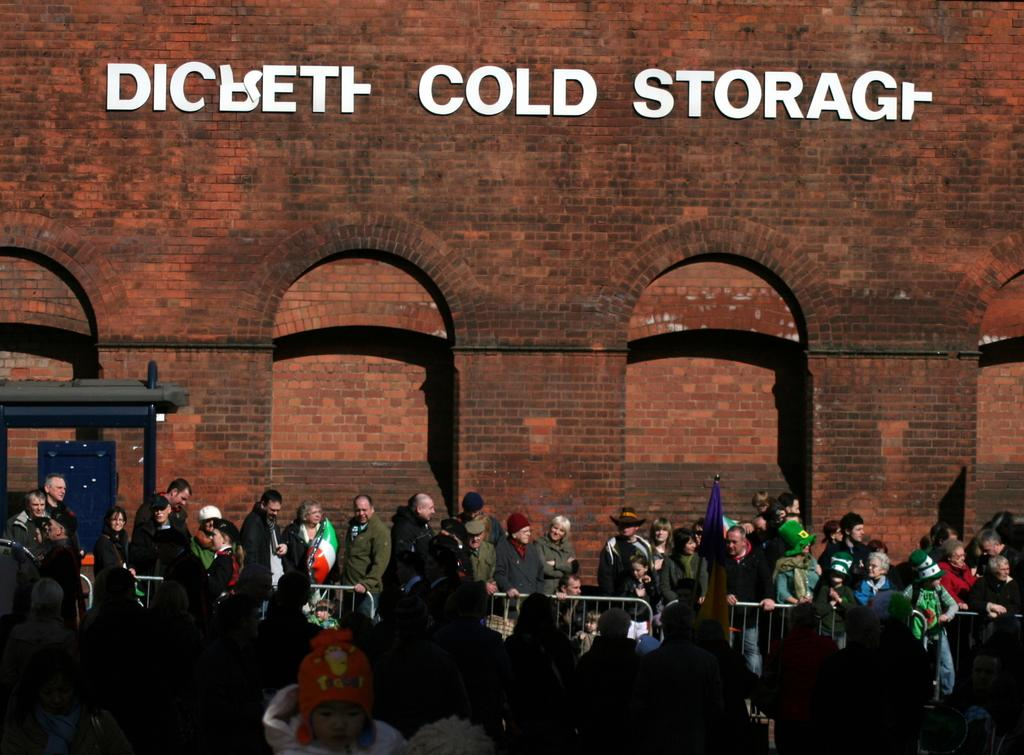What is happening in the center of the image? There are people standing in the center of the image. What can be seen in the image besides the people? There are flags, fences, a building, a wall, a banner, and other unspecified objects in the background of the image. Can you describe the flags in the image? The facts facts facts facts facts facts facts facts facts facts facts facts facts facts facts facts facts facts facts facts facts facts facts facts facts facts facts facts facts facts facts facts facts facts facts facts facts facts facts facts facts facts facts facts facts facts facts facts facts facts facts facts facts facts facts facts facts facts facts facts facts facts facts facts facts facts facts facts facts facts facts facts facts facts facts facts facts facts facts facts facts facts facts facts facts facts facts facts facts facts facts facts facts facts facts facts facts facts facts facts facts facts facts facts facts facts facts facts facts facts facts facts facts facts facts facts facts facts facts facts facts facts facts facts facts facts facts facts facts facts facts facts facts facts facts facts facts facts facts facts facts facts facts facts facts facts facts facts facts facts facts facts facts facts facts facts facts facts facts facts facts facts facts facts facts facts facts facts facts facts facts facts facts facts facts facts facts facts facts facts facts facts facts facts facts facts facts facts facts facts facts facts facts facts facts facts facts facts facts facts facts facts facts facts facts facts facts facts facts facts facts facts facts facts facts facts facts facts facts facts facts facts facts facts facts facts facts facts facts facts facts facts facts facts facts facts facts facts facts facts facts facts facts facts facts facts facts facts facts facts facts facts facts facts facts facts facts facts facts facts facts facts facts facts facts facts facts facts facts facts facts facts facts facts facts facts facts facts facts facts facts facts facts facts facts facts facts facts facts facts facts facts facts facts facts facts facts facts facts facts facts facts facts facts facts facts facts facts facts facts facts facts facts facts facts facts facts facts facts facts facts facts facts facts facts facts facts facts facts facts facts facts facts facts facts facts facts facts facts facts facts facts facts facts facts facts facts facts facts facts facts facts facts facts facts facts facts facts facts facts facts facts facts facts facts facts facts facts facts facts facts facts facts facts facts facts facts facts facts facts facts facts facts facts facts facts facts facts facts facts facts facts facts facts facts facts facts facts facts facts facts facts facts facts facts facts facts facts facts facts facts facts facts facts facts facts facts facts facts facts facts facts facts facts facts facts facts facts facts facts facts facts facts facts facts facts facts facts facts facts facts facts facts facts facts facts facts facts facts facts facts facts facts facts facts facts facts facts facts facts facts facts facts facts facts facts facts facts facts facts facts facts facts facts facts facts facts facts facts facts facts facts facts facts facts facts facts facts facts facts facts facts facts facts facts facts facts facts facts facts facts facts facts facts facts facts facts facts facts facts facts facts facts facts facts facts facts facts facts facts facts facts facts facts facts facts facts facts facts facts facts facts facts facts facts facts facts facts facts facts facts facts facts facts facts facts facts facts facts facts facts facts facts facts facts facts facts facts facts facts facts facts facts facts facts facts facts facts facts facts facts facts facts facts facts facts facts facts facts facts facts facts facts facts facts facts facts facts facts facts facts facts facts facts facts facts facts facts facts facts facts facts facts facts facts facts facts facts facts facts facts facts facts facts facts facts facts facts facts facts facts facts facts facts facts facts facts facts facts facts facts facts facts facts facts facts facts facts facts facts facts facts facts facts facts facts facts facts facts facts facts facts facts facts facts facts facts facts facts facts facts facts facts facts facts facts facts facts facts facts facts facts facts facts facts facts facts facts facts facts facts facts facts facts What action is the writer performing in the image? There is no writer present in the image. Can you describe the turn the action figure takes in the image? There is no action figure present in the image. 